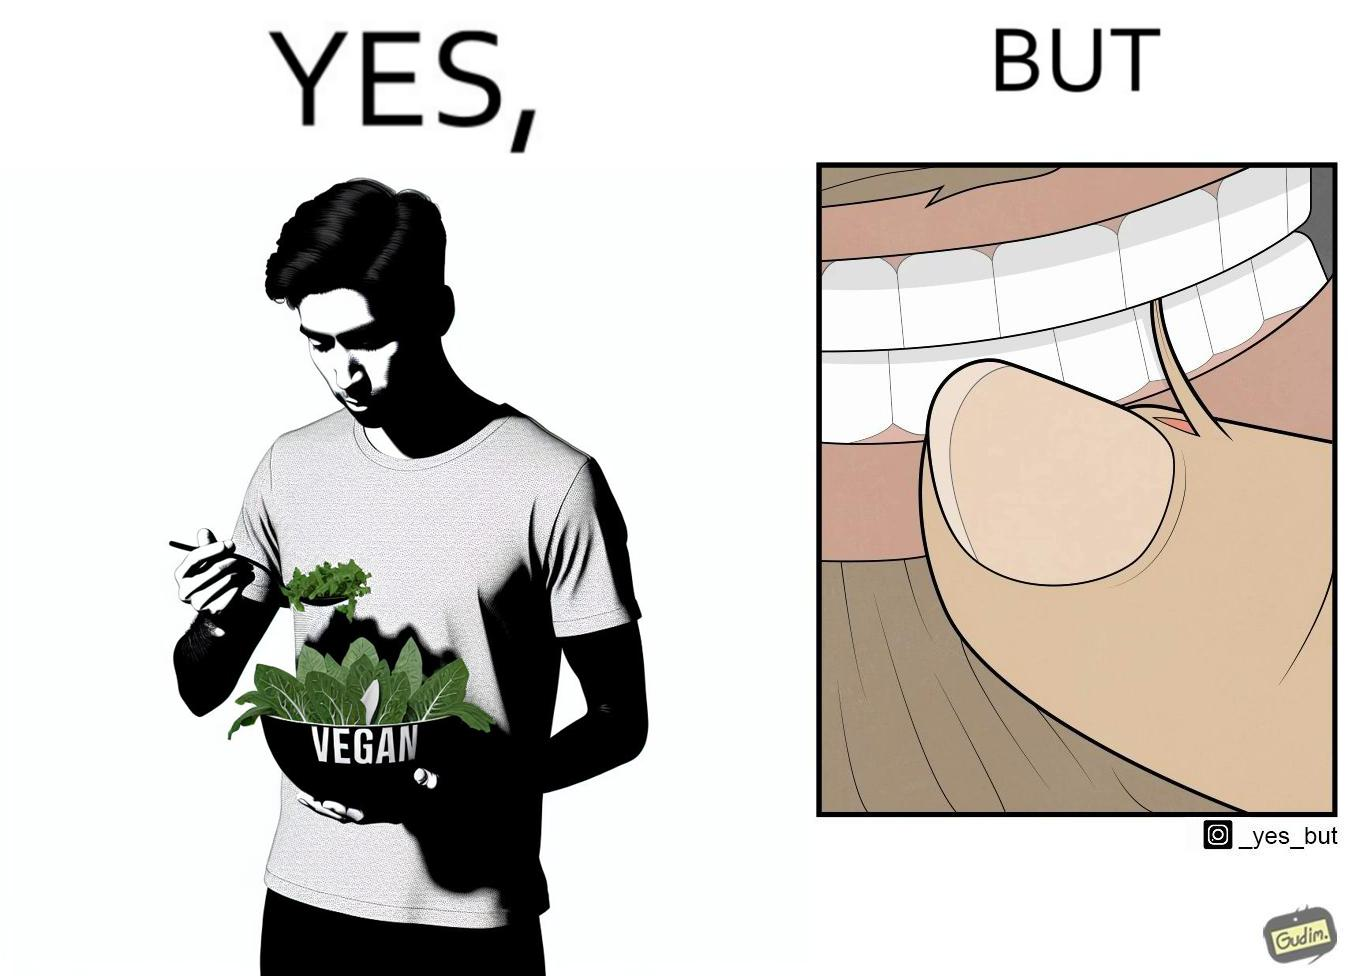Describe what you see in the left and right parts of this image. In the left part of the image: The image shows a man eating leafy vegetables out of a bowl in his hand. He is also wearing a t-shirt that says vegan. In the right part of the image: The image shows a person biting the skin around the fingernails of thier hand. 